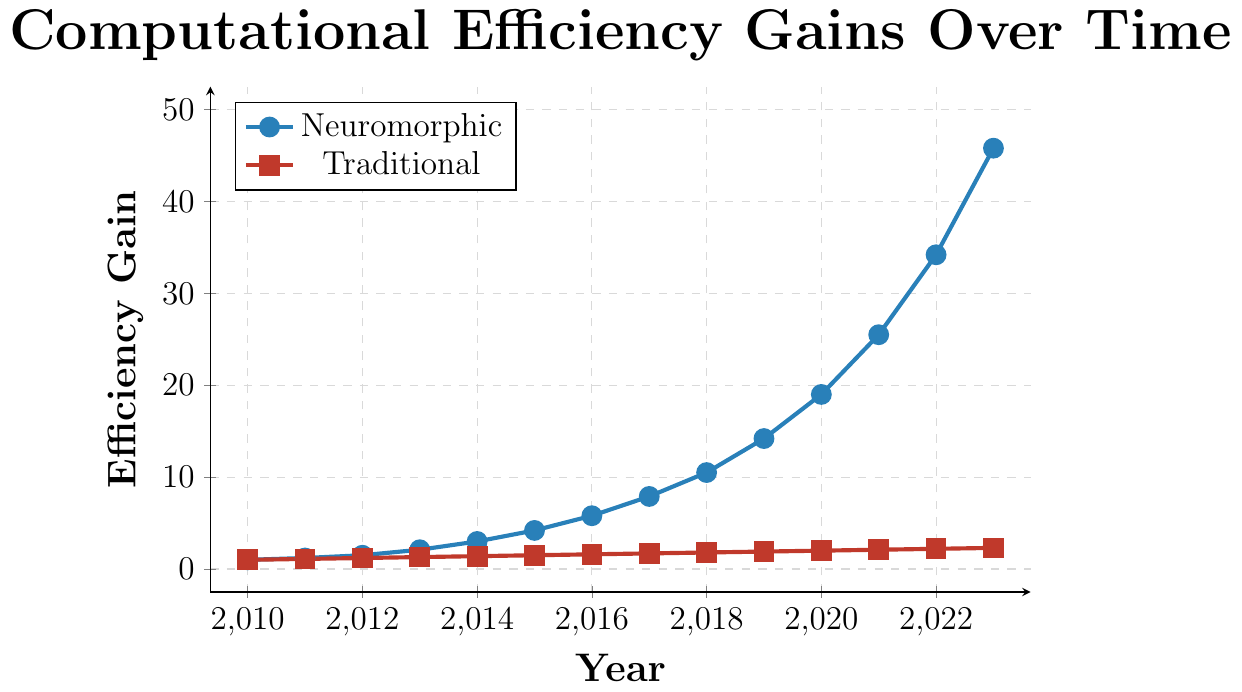What's the efficiency gain of Neuromorphic computing in 2023? The Neuromorphic efficiency gain in 2023 is represented by the point on the blue line corresponding to the year 2023, which is 45.8.
Answer: 45.8 How does the efficiency gain of traditional processors in 2015 compare to that in 2010? The efficiency gain for traditional processors in 2015 is 1.5, as shown by the red line at 2015. In 2010, the efficiency gain is 1. This shows an increase from 1 to 1.5.
Answer: It increased from 1 to 1.5 What is the difference in the efficiency gain between Neuromorphic computing and traditional processors in 2020? In 2020, the Neuromorphic efficiency gain is 19.0 and the traditional processor efficiency gain is 2.0. The difference is calculated as 19.0 - 2.0.
Answer: 17.0 In which year did Neuromorphic computing efficiency gain first exceed 10? Looking at the blue line for Neuromorphic efficiency gain, it exceeds 10 at 2018 where it reaches 10.5.
Answer: 2018 What is the average efficiency gain of traditional processors between 2020 and 2023? The values for traditional processor efficiency gains between 2020 and 2023 are 2.0, 2.1, 2.2, and 2.3. The average is calculated as (2.0 + 2.1 + 2.2 + 2.3) / 4.
Answer: 2.15 In 2017, by how much did the efficiency gain from Neuromorphic computing exceed that of traditional processors? In 2017, the Neuromorphic efficiency gain is 7.9, and the traditional processor efficiency gain is 1.7. The difference is 7.9 - 1.7.
Answer: 6.2 Describe the trend of Neuromorphic efficiency gain from 2010 to 2023. The blue line representing Neuromorphic efficiency gain shows a consistently increasing trend from almost flat at the beginning to a rapid increase towards 2023.
Answer: Increasing rapidly Which color in the plot represents traditional processors? The legend shows that the red line with square markers represents traditional processors.
Answer: Red What is the total efficiency gain for traditional processors over the entire period? Summing the efficiency gains for traditional processors from 2010 to 2023: 1 + 1.1 + 1.2 + 1.3 + 1.4 + 1.5 + 1.6 + 1.7 + 1.8 + 1.9 + 2.0 + 2.1 + 2.2 + 2.3.
Answer: 23.3 